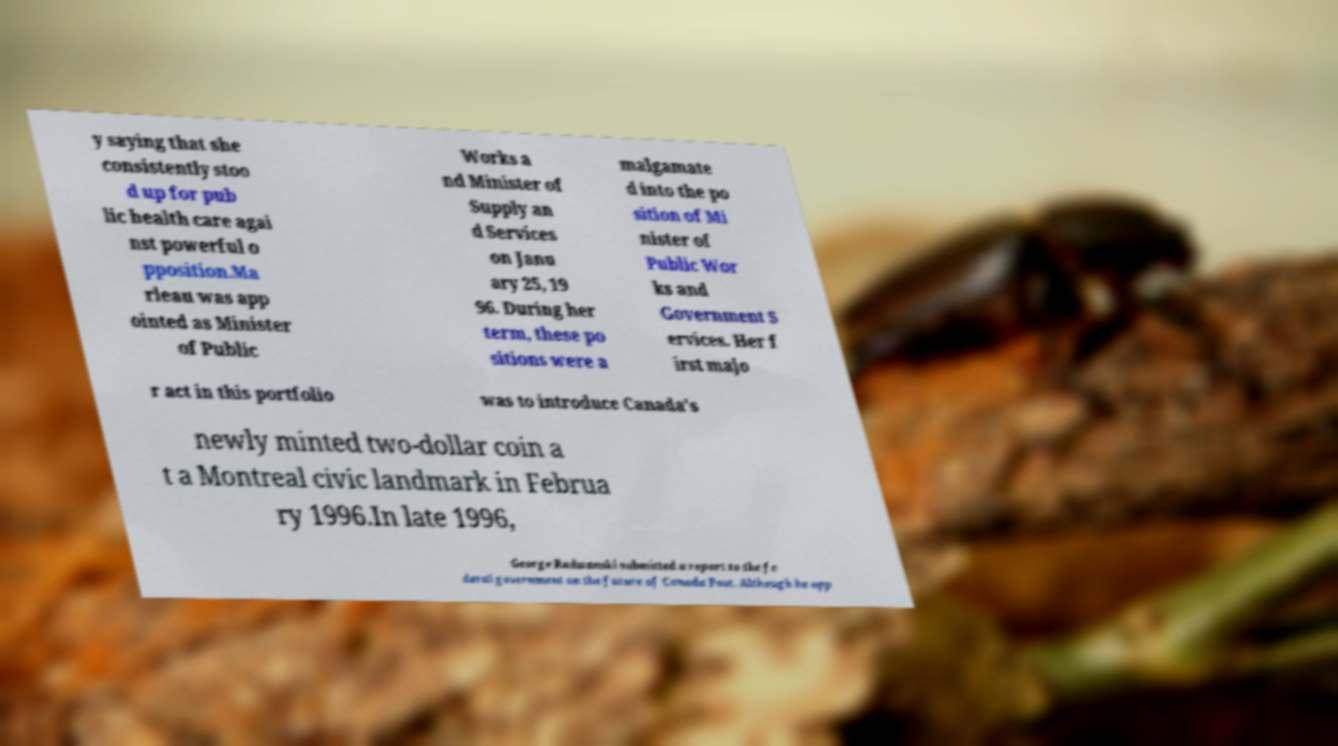Could you extract and type out the text from this image? y saying that she consistently stoo d up for pub lic health care agai nst powerful o pposition.Ma rleau was app ointed as Minister of Public Works a nd Minister of Supply an d Services on Janu ary 25, 19 96. During her term, these po sitions were a malgamate d into the po sition of Mi nister of Public Wor ks and Government S ervices. Her f irst majo r act in this portfolio was to introduce Canada's newly minted two-dollar coin a t a Montreal civic landmark in Februa ry 1996.In late 1996, George Radwanski submitted a report to the fe deral government on the future of Canada Post. Although he opp 